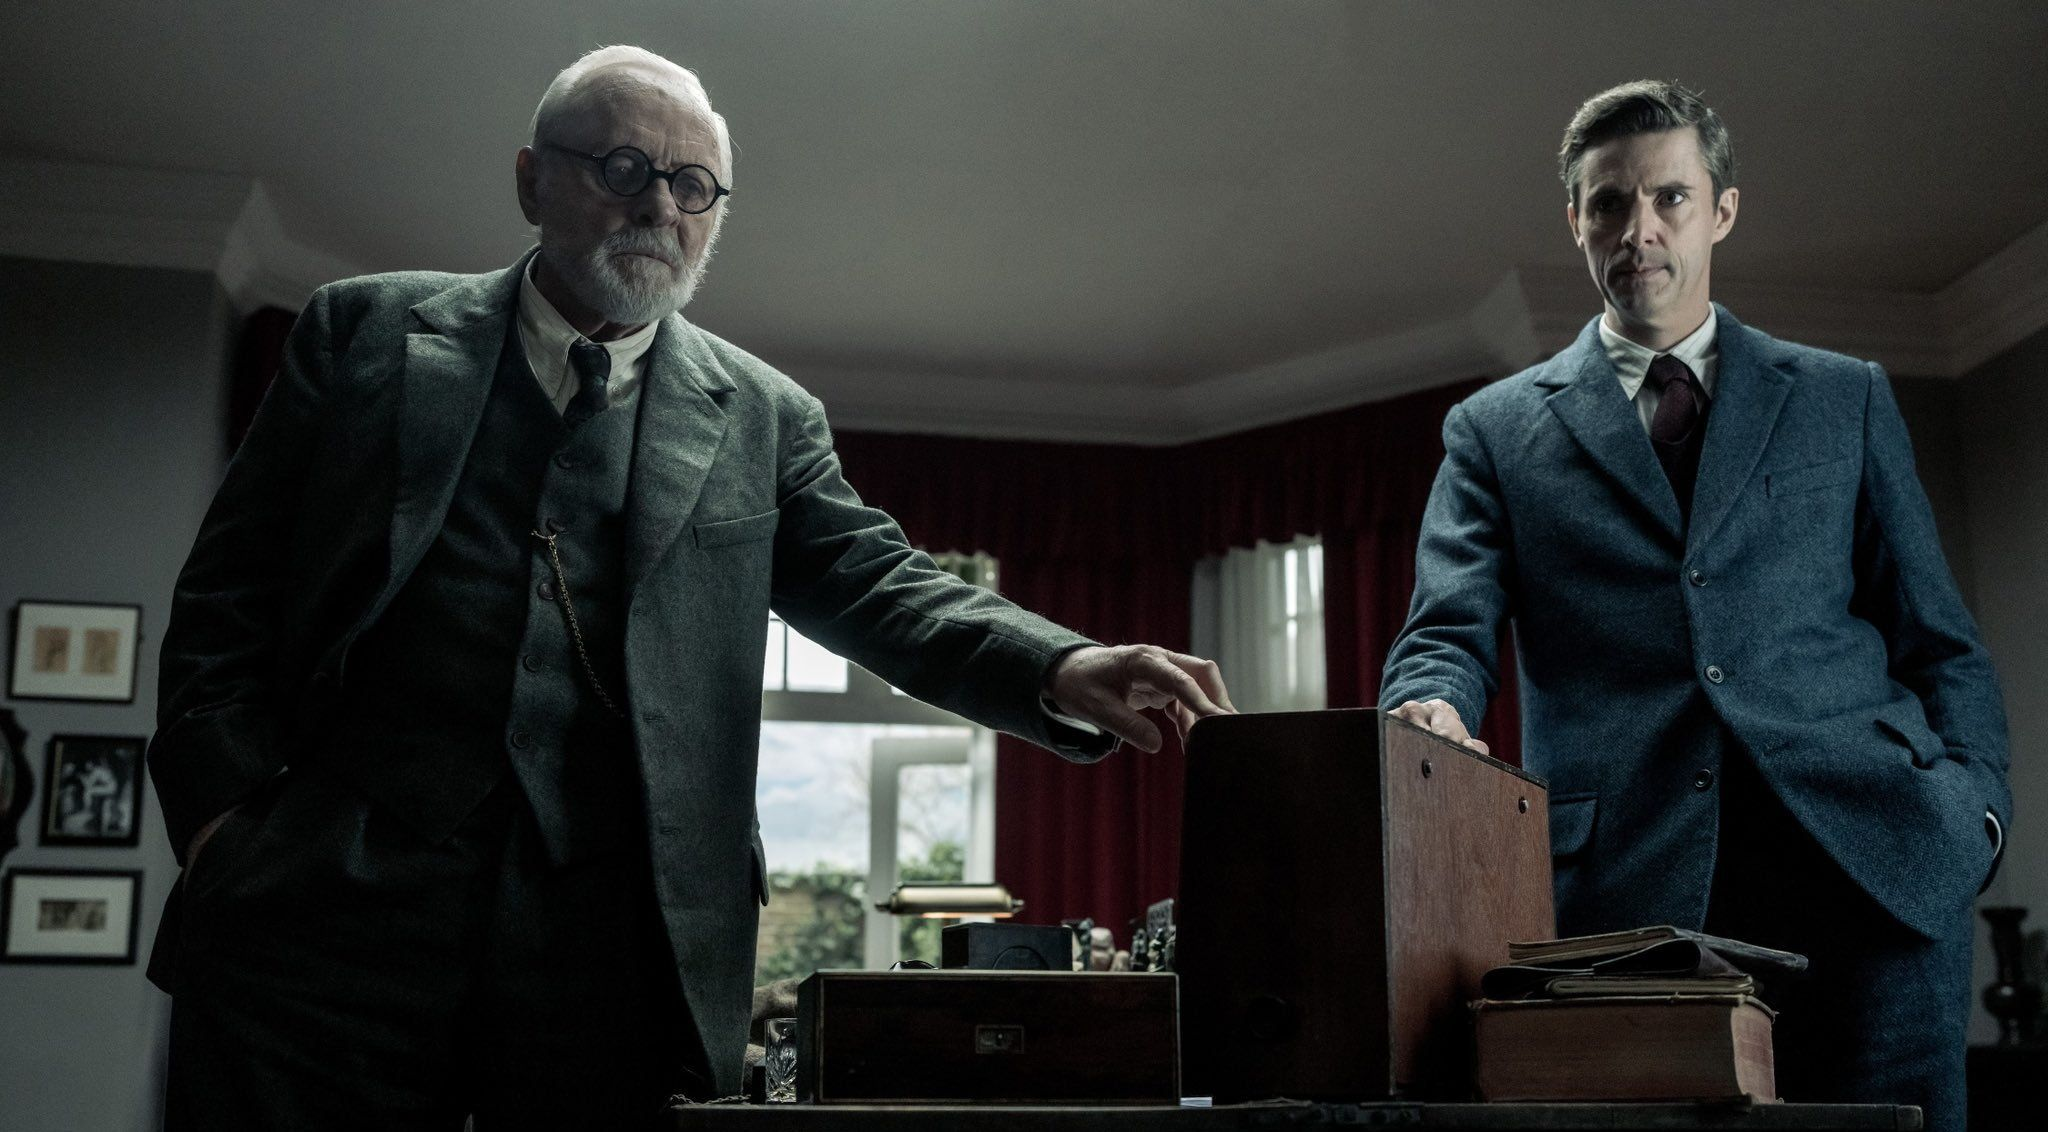Describe a very realistic scenario that might be happening in this scene. The elderly man, a senior partner at a law firm, is discussing a critical legal case with the younger man, a junior associate. The box contains confidential case files and evidence needed for their upcoming courtroom battle. Their exchange is tense, as they strategize on how to tackle the challenging case ahead. 